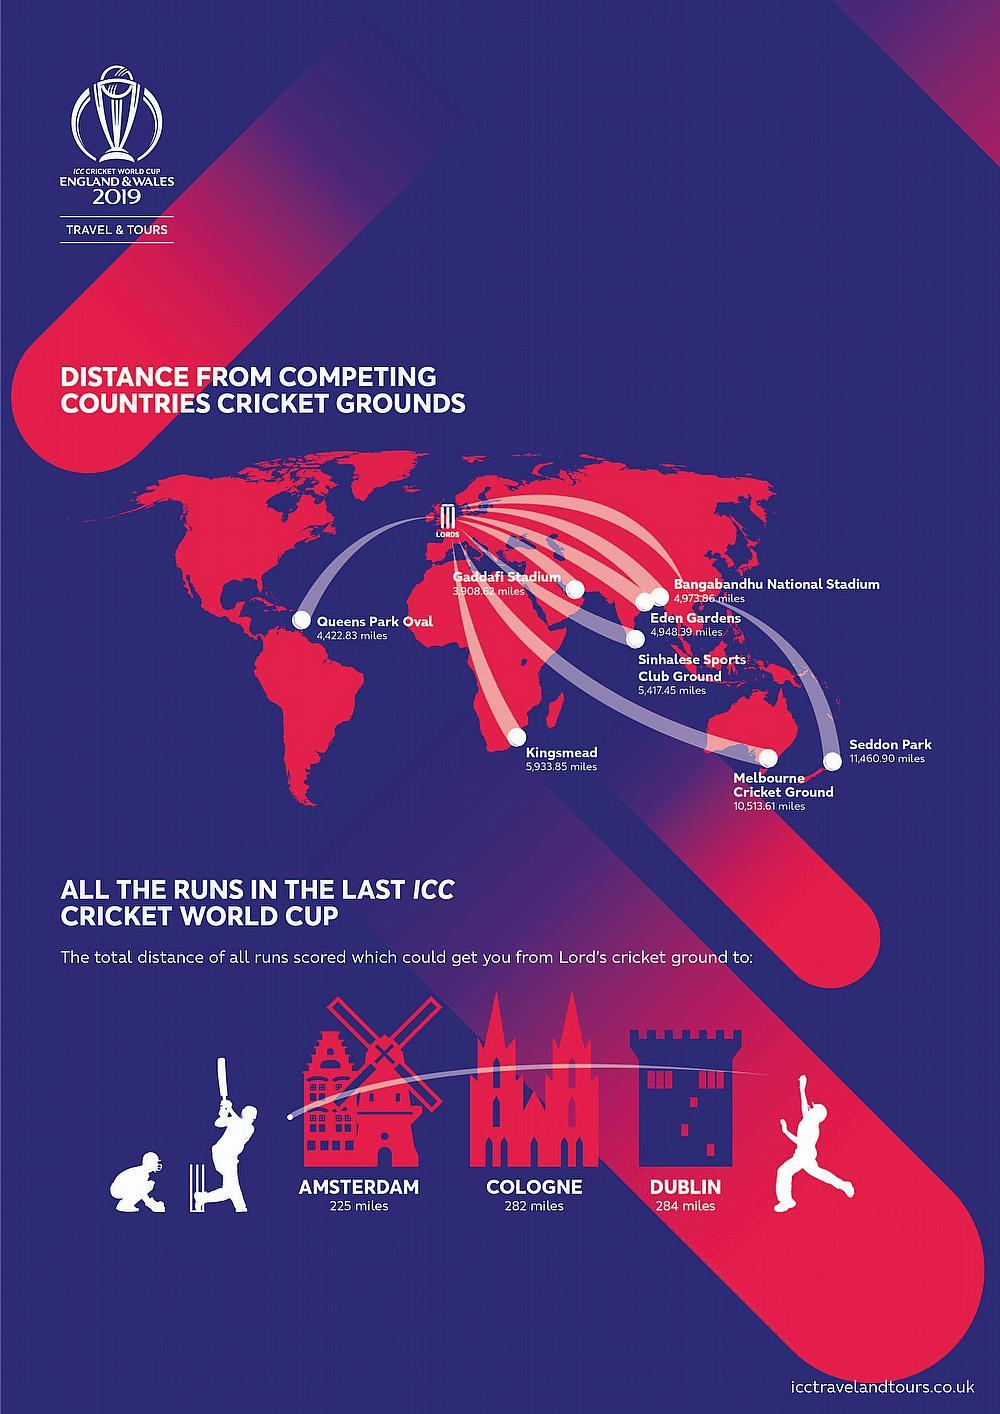Give some essential details in this illustration. Eden Gardens, a stadium located in India, is a well-known sports arena. The Sinhalese Sports Club Ground is the stadium located in Sri Lanka. The distance between Lords Cricket Ground and the Melbourne Cricket Ground is approximately 10,513.61 miles. The stadium located in Africa is Kingsmead. The Queens Park Oval stadium is located in the American continent. 